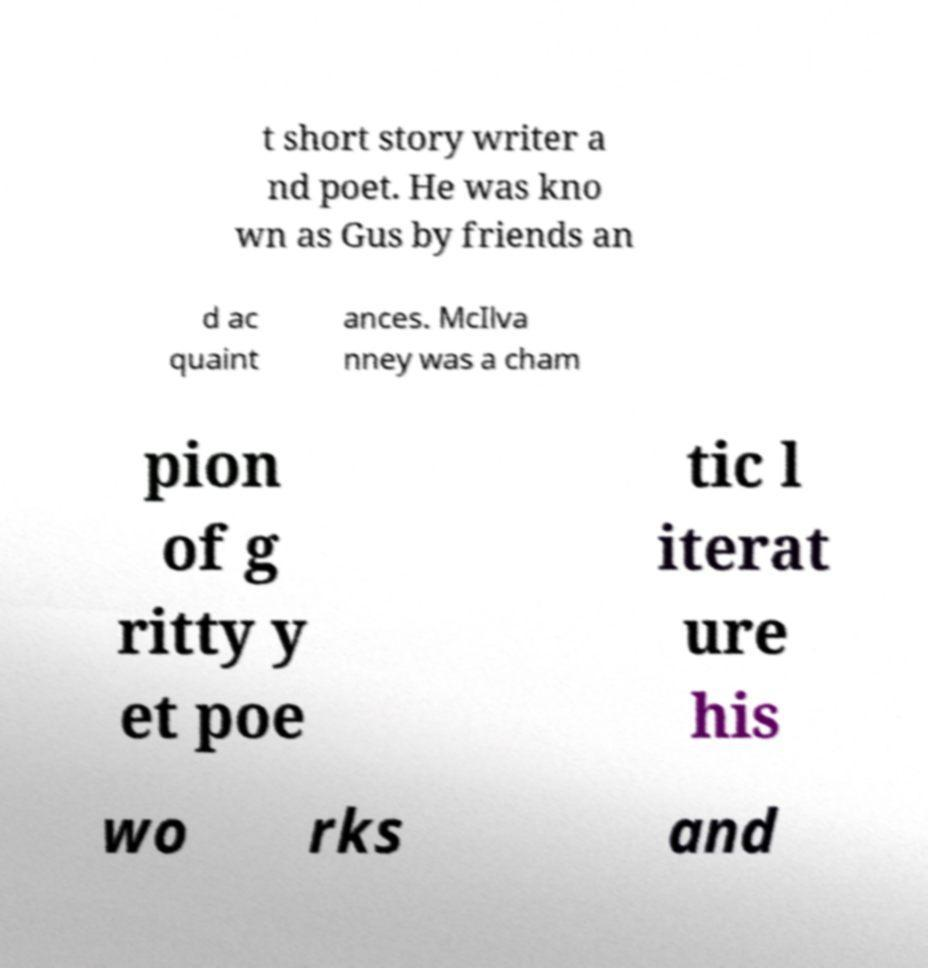I need the written content from this picture converted into text. Can you do that? t short story writer a nd poet. He was kno wn as Gus by friends an d ac quaint ances. McIlva nney was a cham pion of g ritty y et poe tic l iterat ure his wo rks and 